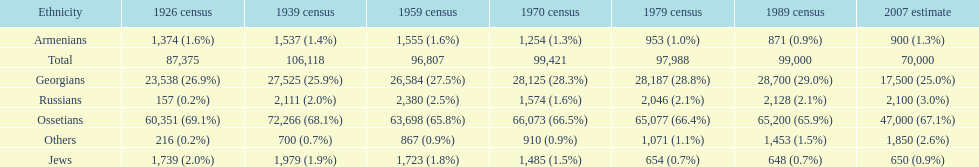How many russians lived in south ossetia in 1970? 1,574. 